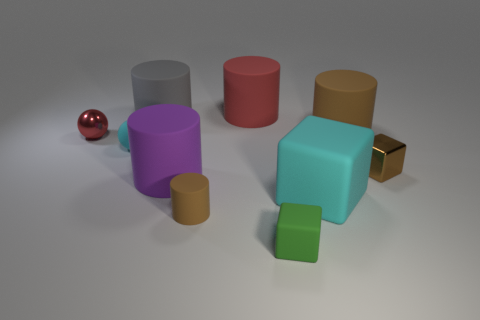What number of tiny things are either yellow rubber blocks or red spheres?
Provide a succinct answer. 1. What number of matte things are behind the red metallic sphere?
Your response must be concise. 3. Are there any large objects of the same color as the small matte sphere?
Make the answer very short. Yes. There is a purple object that is the same size as the cyan cube; what is its shape?
Offer a terse response. Cylinder. What number of cyan objects are either matte things or shiny cylinders?
Offer a terse response. 2. How many metallic blocks have the same size as the red cylinder?
Provide a short and direct response. 0. There is a large thing that is the same color as the rubber ball; what is its shape?
Give a very brief answer. Cube. What number of things are either green metallic blocks or matte blocks that are to the right of the green matte cube?
Keep it short and to the point. 1. Do the brown thing left of the big red matte cylinder and the metal thing that is to the left of the green block have the same size?
Offer a terse response. Yes. What number of other things are the same shape as the red shiny object?
Give a very brief answer. 1. 